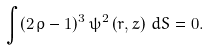Convert formula to latex. <formula><loc_0><loc_0><loc_500><loc_500>\int ( 2 \, \rho - 1 ) ^ { 3 } \, { \psi ^ { 2 } \left ( r , z \right ) \, d S } = 0 .</formula> 